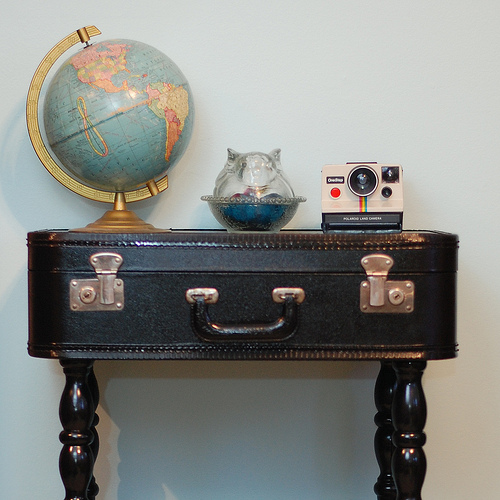<image>
Can you confirm if the globe is to the left of the camera? Yes. From this viewpoint, the globe is positioned to the left side relative to the camera. 